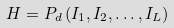<formula> <loc_0><loc_0><loc_500><loc_500>H = P _ { d } \left ( I _ { 1 } , I _ { 2 } , \dots , I _ { L } \right )</formula> 